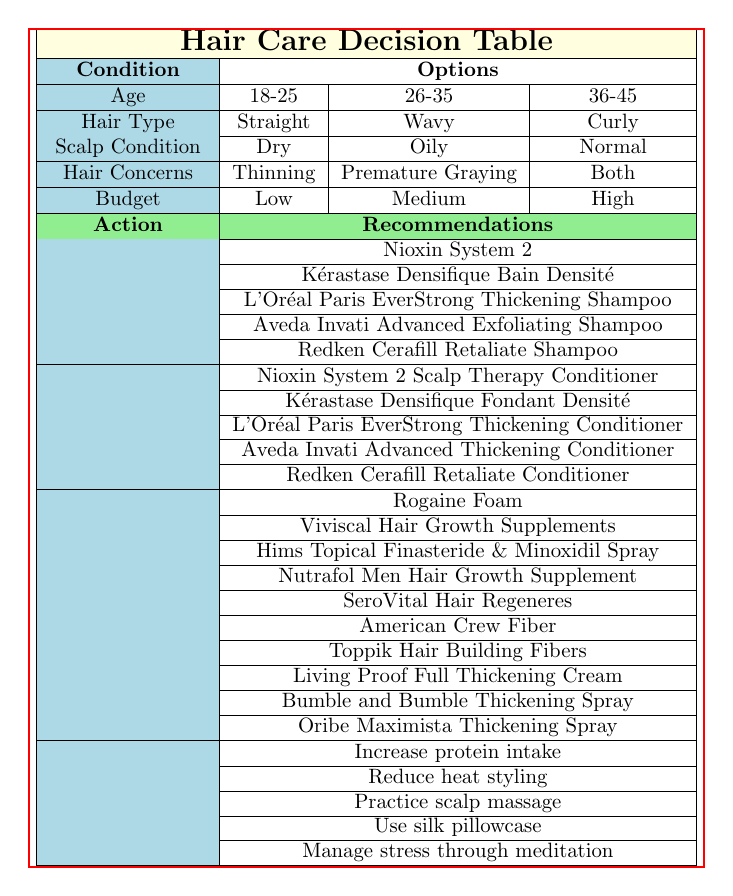What shampoo is recommended for someone aged 18-25 with oily scalp and concerns about thinning hair? According to the table, for the age group of 18-25, oily scalp, and hair concern of thinning, the shampoo recommendation is "Nioxin System 2" as it is applicable to most segments of the table under these conditions.
Answer: Nioxin System 2 Is "Viviscal Hair Growth Supplements" recommended for all hair types? No. The table does not specify that Viviscal is suitable for all hair types. Recommendations vary based on age, hair type, and specific concerns, indicating it may not universally apply across all conditions listed.
Answer: No What is the budget range for using "Hims Topical Finasteride & Minoxidil Spray"? The table does not explicitly specify a budget range for "Hims Topical Finasteride & Minoxidil Spray". However, by general awareness, these treatments are often categorized under medium to high budget.
Answer: Medium to high If a person is 36-45 years old, has curly hair, and is concerned about both thinning and premature graying, what styling product is recommended? The table shows that for someone aged 36-45 with curly hair and concerns of both thinning and premature graying, the recommended styling product is "American Crew Fiber." Individual product recommendations primarily align with the age and specific concerns.
Answer: American Crew Fiber Is it advisable to reduce heat styling as part of a hair care regimen? Yes, the table lists “Reduce heat styling” as a lifestyle recommendation which suggests that it is a positive practice to prevent hair concerns.
Answer: Yes Which conditioner is recommended for individuals aged 26-35 with dry scalp and hair concerns about premature graying? According to the table, the conditioner recommended for individuals aged 26-35 with a dry scalp and concerns about premature graying is "Kérastase Densifique Fondant Densité." It aligns with that specific combination of conditions in the table.
Answer: Kérastase Densifique Fondant Densité What actions should someone in the 18-25 age group with normal hair and no specific concerns take? The table does not provide specific product recommendations for someone aged 18-25 with normal hair and no specific hair concerns. However, lifestyle recommendations such as "Increase protein intake" and "Manage stress through meditation" would be advisable since they are general and benefit overall hair health.
Answer: Lifestyle recommendations can be useful For someone with a low budget, which shampoo should they consider for thinning hair? The table does not specify a low-budget shampoo specifically for thinning hair. However, “L'Oréal Paris EverStrong Thickening Shampoo” can generally align with lower budget options in a broader market context, while “Nioxin System 2” is widely known but not explicitly stated as low budget in the context of this table's framework.
Answer: L'Oréal Paris EverStrong Thickening Shampoo Is “Nutrafol Men Hair Growth Supplement” suitable for both men and women? The table implies recommendations without gender distinction. However, "Nutrafol Men" is primarily marketed for men’s hair growth, suggesting it is tailored more for men, making it not suitable for women based on its targeted marketing.
Answer: No 